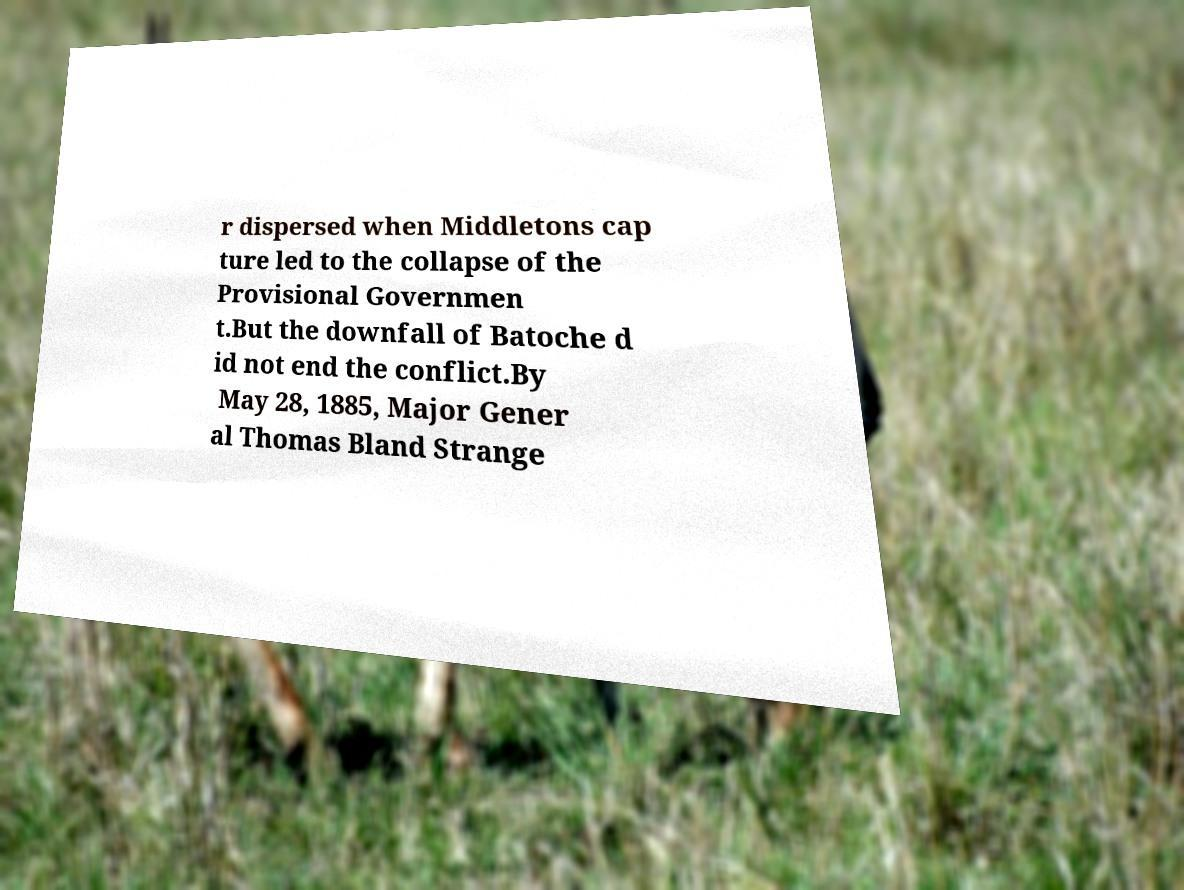Could you assist in decoding the text presented in this image and type it out clearly? r dispersed when Middletons cap ture led to the collapse of the Provisional Governmen t.But the downfall of Batoche d id not end the conflict.By May 28, 1885, Major Gener al Thomas Bland Strange 